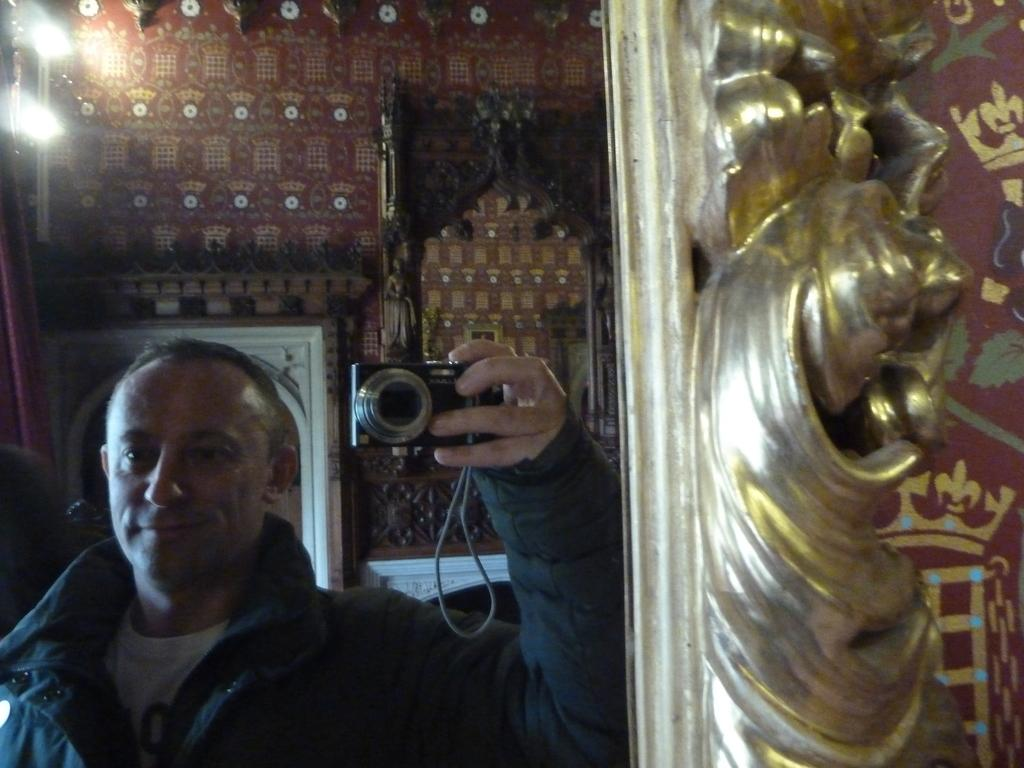What is the person in the image doing? The person is holding a camera in the image. How can the person be seen in the image? The person is visible through a mirror. What can be seen in the background of the image? There is a wall in the background of the image. What type of lace can be seen on the cushion in the image? There is no cushion or lace present in the image. How does the plane in the image affect the person holding the camera? There is no plane present in the image, so it does not affect the person holding the camera. 